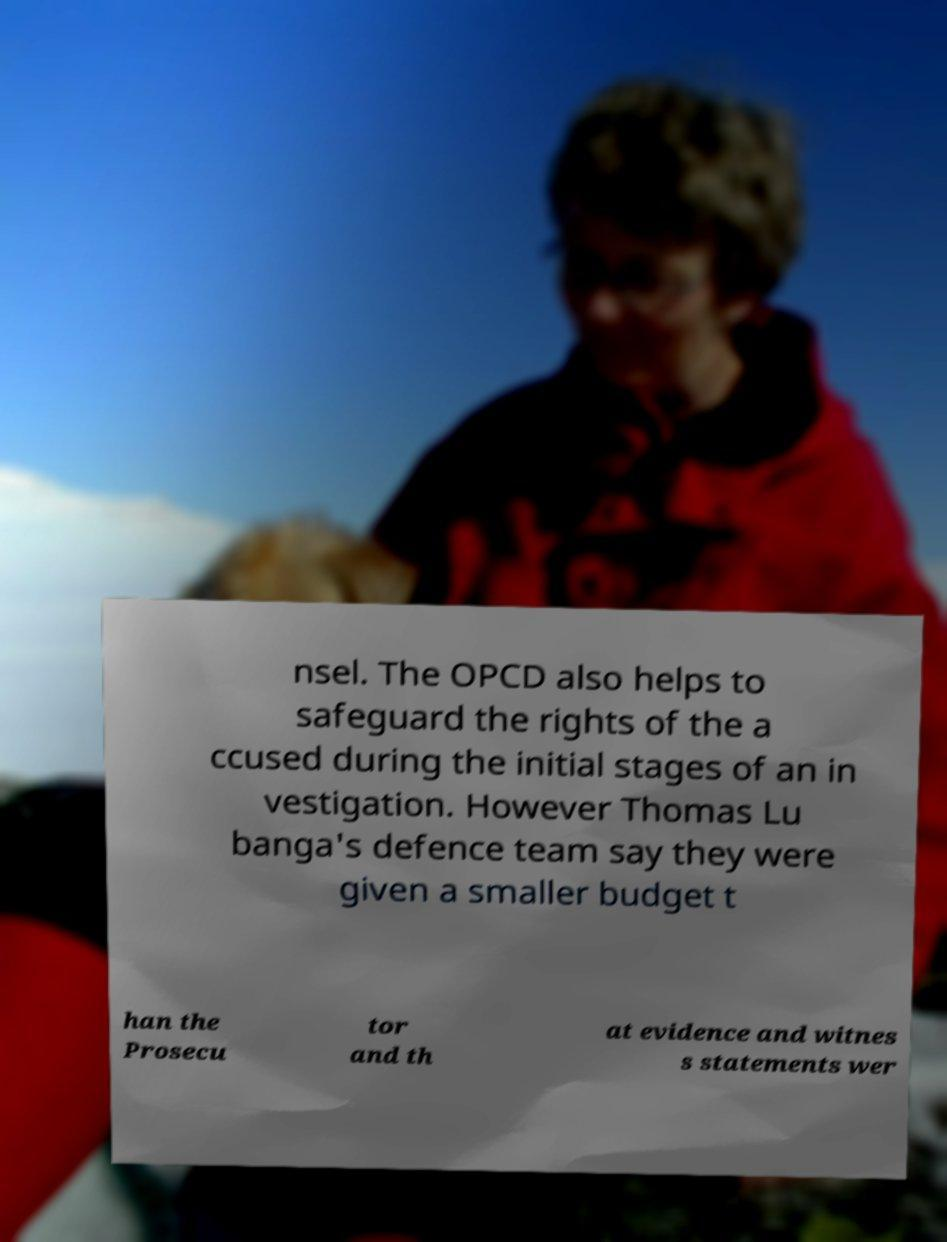Can you read and provide the text displayed in the image?This photo seems to have some interesting text. Can you extract and type it out for me? nsel. The OPCD also helps to safeguard the rights of the a ccused during the initial stages of an in vestigation. However Thomas Lu banga's defence team say they were given a smaller budget t han the Prosecu tor and th at evidence and witnes s statements wer 